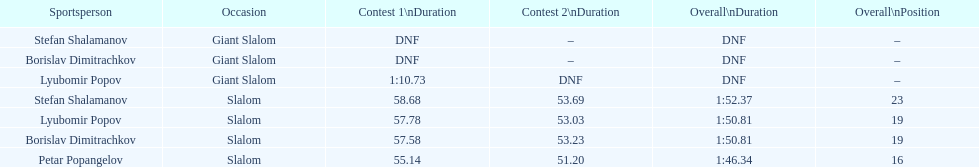Who has the highest rank? Petar Popangelov. 